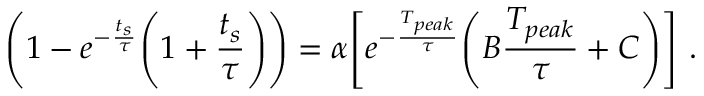<formula> <loc_0><loc_0><loc_500><loc_500>\left ( 1 - e ^ { - \frac { t _ { s } } { \tau } } \left ( 1 + \frac { t _ { s } } { \tau } \right ) \right ) = \alpha \left [ e ^ { - \frac { T _ { p e a k } } { \tau } } \left ( B \frac { T _ { p e a k } } { \tau } + C \right ) \right ] .</formula> 